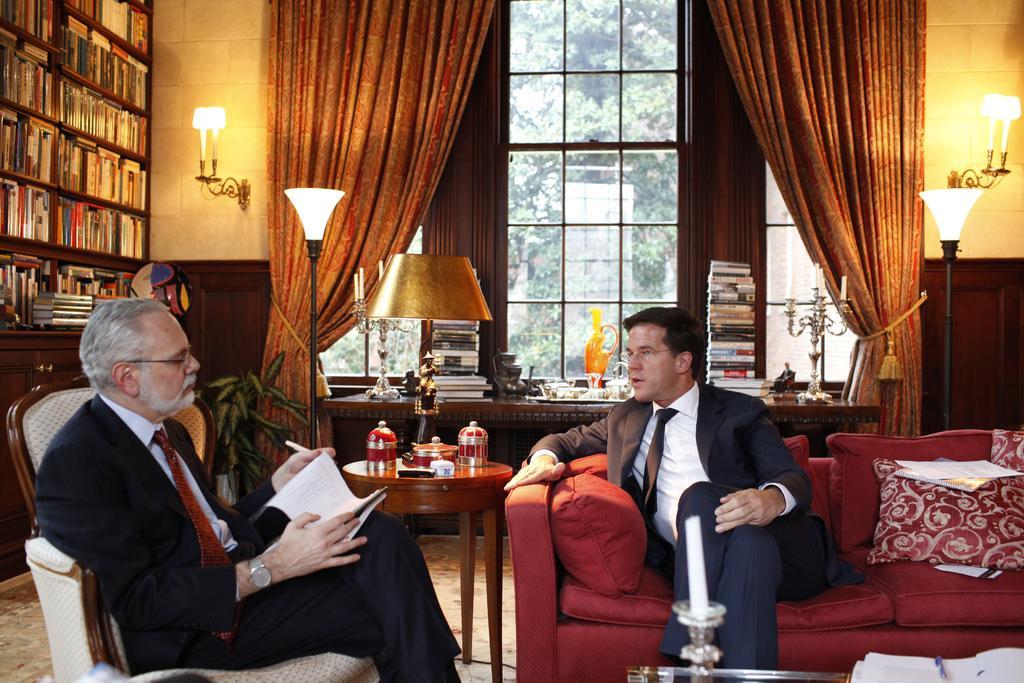Describe this image in one or two sentences. These two persons are sitting and talking, this person holding paper and pen. We can see tables ,chairs,sofa,on the tables we can see books,pen and objects. Behind these two persons we can see glass window,curtain,wall,lights,from this glass window we can see trees. We can see shelves with books. This is floor. 